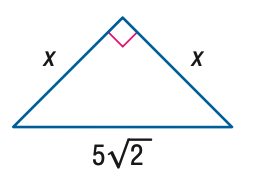Answer the mathemtical geometry problem and directly provide the correct option letter.
Question: Find x.
Choices: A: \frac { 5 } { 2 } \sqrt { 2 } B: 5 C: 5 \sqrt { 2 } D: 10 B 